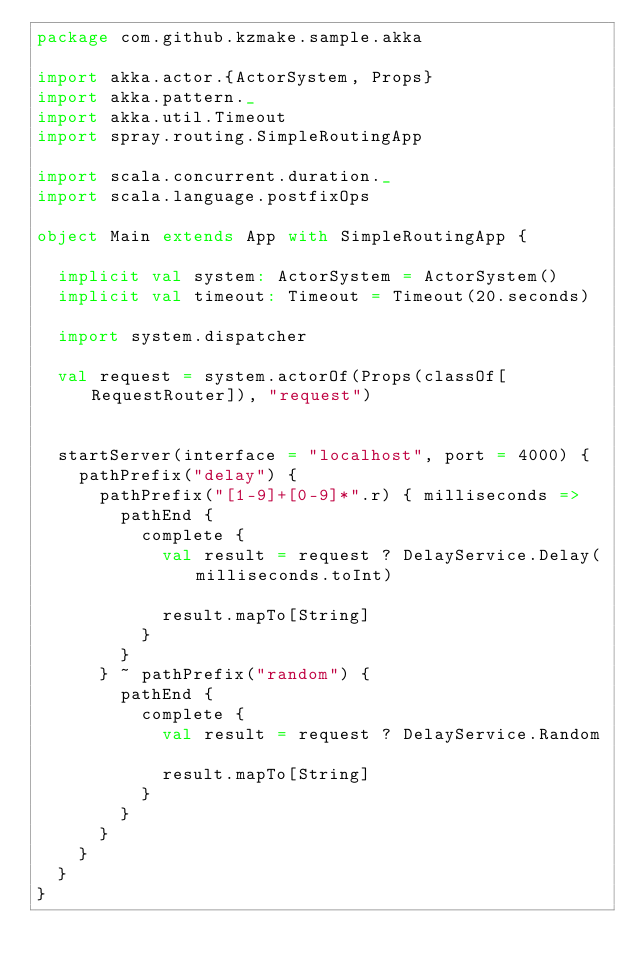Convert code to text. <code><loc_0><loc_0><loc_500><loc_500><_Scala_>package com.github.kzmake.sample.akka

import akka.actor.{ActorSystem, Props}
import akka.pattern._
import akka.util.Timeout
import spray.routing.SimpleRoutingApp

import scala.concurrent.duration._
import scala.language.postfixOps

object Main extends App with SimpleRoutingApp {

  implicit val system: ActorSystem = ActorSystem()
  implicit val timeout: Timeout = Timeout(20.seconds)

  import system.dispatcher

  val request = system.actorOf(Props(classOf[RequestRouter]), "request")


  startServer(interface = "localhost", port = 4000) {
    pathPrefix("delay") {
      pathPrefix("[1-9]+[0-9]*".r) { milliseconds =>
        pathEnd {
          complete {
            val result = request ? DelayService.Delay(milliseconds.toInt)

            result.mapTo[String]
          }
        }
      } ~ pathPrefix("random") {
        pathEnd {
          complete {
            val result = request ? DelayService.Random

            result.mapTo[String]
          }
        }
      }
    }
  }
}
</code> 